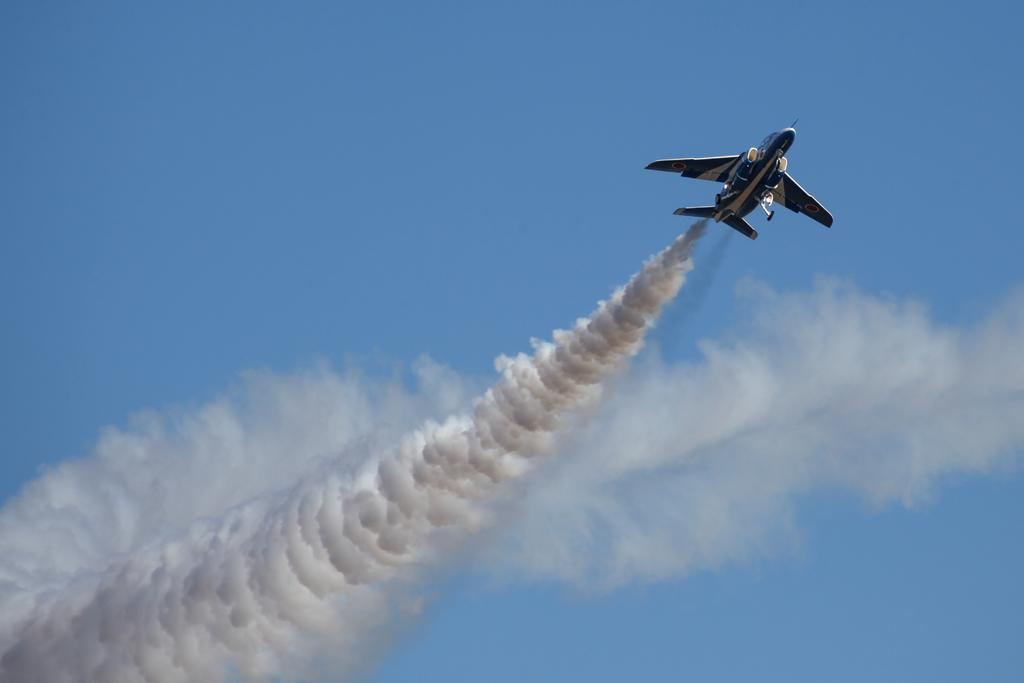What is the main subject of the image? The main subject of the image is an aircraft. What is the aircraft doing in the image? The aircraft is flying in the air. What can be seen coming from the aircraft in the image? There is smoke visible in the image. What color is the sky in the image? The sky is blue in the image. Where is the office located in the image? There is no office present in the image. What type of curve can be seen in the image? There is no curve visible in the image. 